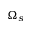Convert formula to latex. <formula><loc_0><loc_0><loc_500><loc_500>\Omega _ { s }</formula> 